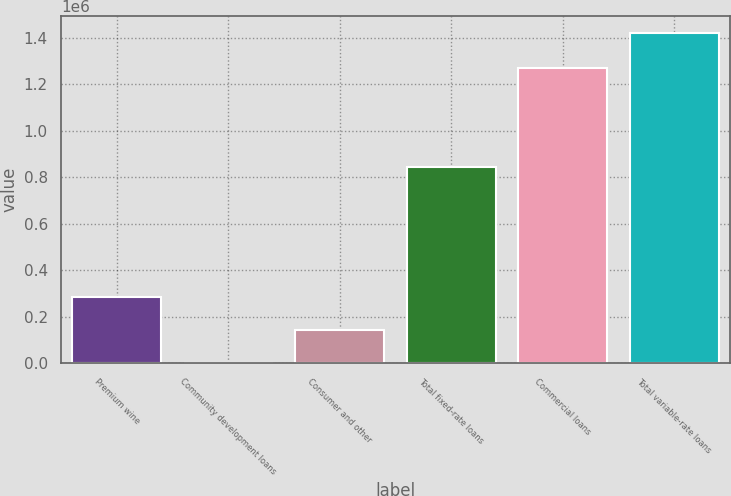Convert chart to OTSL. <chart><loc_0><loc_0><loc_500><loc_500><bar_chart><fcel>Premium wine<fcel>Community development loans<fcel>Consumer and other<fcel>Total fixed-rate loans<fcel>Commercial loans<fcel>Total variable-rate loans<nl><fcel>286165<fcel>2059<fcel>144112<fcel>843218<fcel>1.26988e+06<fcel>1.42259e+06<nl></chart> 